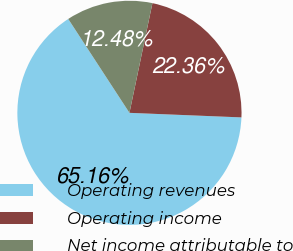Convert chart to OTSL. <chart><loc_0><loc_0><loc_500><loc_500><pie_chart><fcel>Operating revenues<fcel>Operating income<fcel>Net income attributable to<nl><fcel>65.15%<fcel>22.36%<fcel>12.48%<nl></chart> 